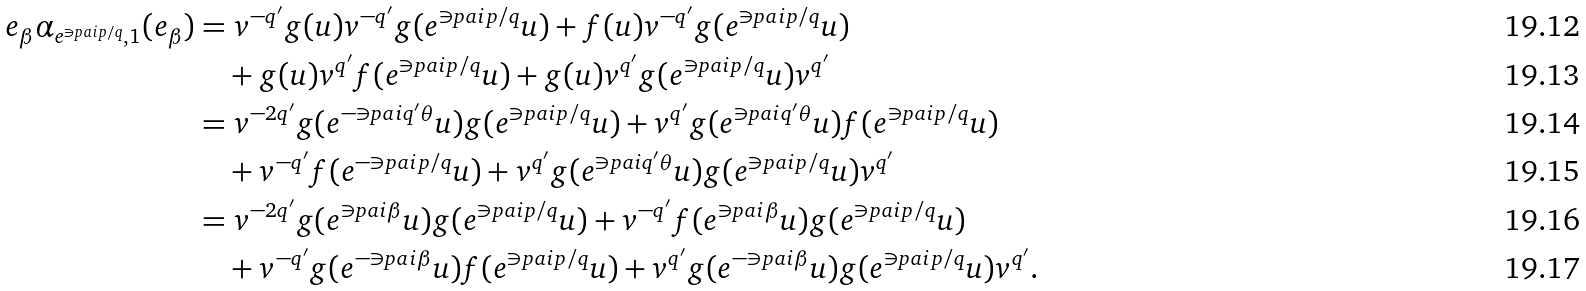Convert formula to latex. <formula><loc_0><loc_0><loc_500><loc_500>e _ { \beta } \alpha _ { e ^ { \ni p a i p / q } , 1 } ( e _ { \beta } ) & = v ^ { - q ^ { \prime } } g ( u ) v ^ { - q ^ { \prime } } g ( e ^ { \ni p a i p / q } u ) + f ( u ) v ^ { - q ^ { \prime } } g ( e ^ { \ni p a i p / q } u ) \\ & \quad + g ( u ) v ^ { q ^ { \prime } } f ( e ^ { \ni p a i p / q } u ) + g ( u ) v ^ { q ^ { \prime } } g ( e ^ { \ni p a i p / q } u ) v ^ { q ^ { \prime } } \\ & = v ^ { - 2 q ^ { \prime } } g ( e ^ { - \ni p a i q ^ { \prime } \theta } u ) g ( e ^ { \ni p a i p / q } u ) + v ^ { q ^ { \prime } } g ( e ^ { \ni p a i q ^ { \prime } \theta } u ) f ( e ^ { \ni p a i p / q } u ) \\ & \quad + v ^ { - q ^ { \prime } } f ( e ^ { - \ni p a i p / q } u ) + v ^ { q ^ { \prime } } g ( e ^ { \ni p a i q ^ { \prime } \theta } u ) g ( e ^ { \ni p a i p / q } u ) v ^ { q ^ { \prime } } \\ & = v ^ { - 2 q ^ { \prime } } g ( e ^ { \ni p a i \beta } u ) g ( e ^ { \ni p a i p / q } u ) + v ^ { - q ^ { \prime } } f ( e ^ { \ni p a i \beta } u ) g ( e ^ { \ni p a i p / q } u ) \\ & \quad + v ^ { - q ^ { \prime } } g ( e ^ { - \ni p a i \beta } u ) f ( e ^ { \ni p a i p / q } u ) + v ^ { q ^ { \prime } } g ( e ^ { - \ni p a i \beta } u ) g ( e ^ { \ni p a i p / q } u ) v ^ { q ^ { \prime } } .</formula> 